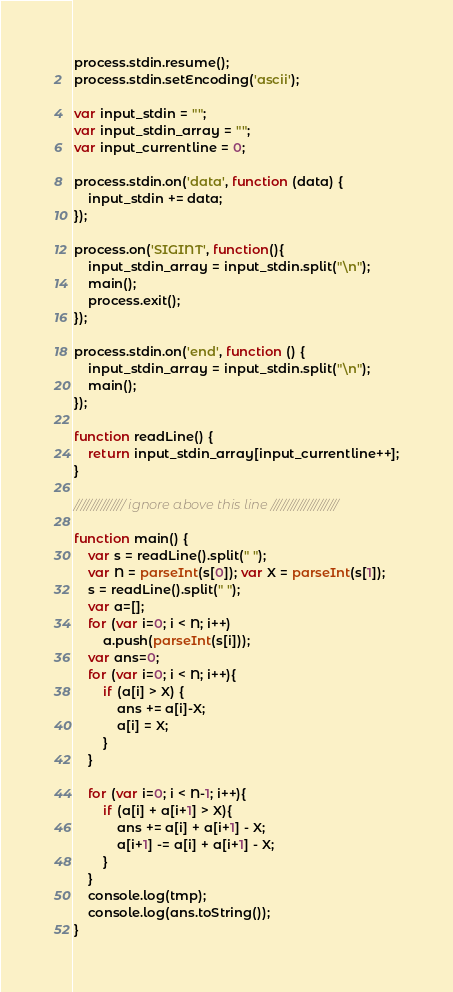Convert code to text. <code><loc_0><loc_0><loc_500><loc_500><_JavaScript_>process.stdin.resume();
process.stdin.setEncoding('ascii');

var input_stdin = "";
var input_stdin_array = "";
var input_currentline = 0;

process.stdin.on('data', function (data) {
    input_stdin += data;
});

process.on('SIGINT', function(){
    input_stdin_array = input_stdin.split("\n");
    main();
    process.exit();
});

process.stdin.on('end', function () {
    input_stdin_array = input_stdin.split("\n");
    main();    
});

function readLine() {
    return input_stdin_array[input_currentline++];
}

/////////////// ignore above this line ////////////////////

function main() {
	var s = readLine().split(" ");
	var N = parseInt(s[0]); var X = parseInt(s[1]);
	s = readLine().split(" ");
	var a=[];
	for (var i=0; i < N; i++) 
		a.push(parseInt(s[i]));
	var ans=0;
	for (var i=0; i < N; i++){
		if (a[i] > X) {
			ans += a[i]-X;
			a[i] = X;
		}
	}
	
	for (var i=0; i < N-1; i++){
		if (a[i] + a[i+1] > X){
			ans += a[i] + a[i+1] - X;
			a[i+1] -= a[i] + a[i+1] - X;
		}
	}
	console.log(tmp);
	console.log(ans.toString());
}
</code> 